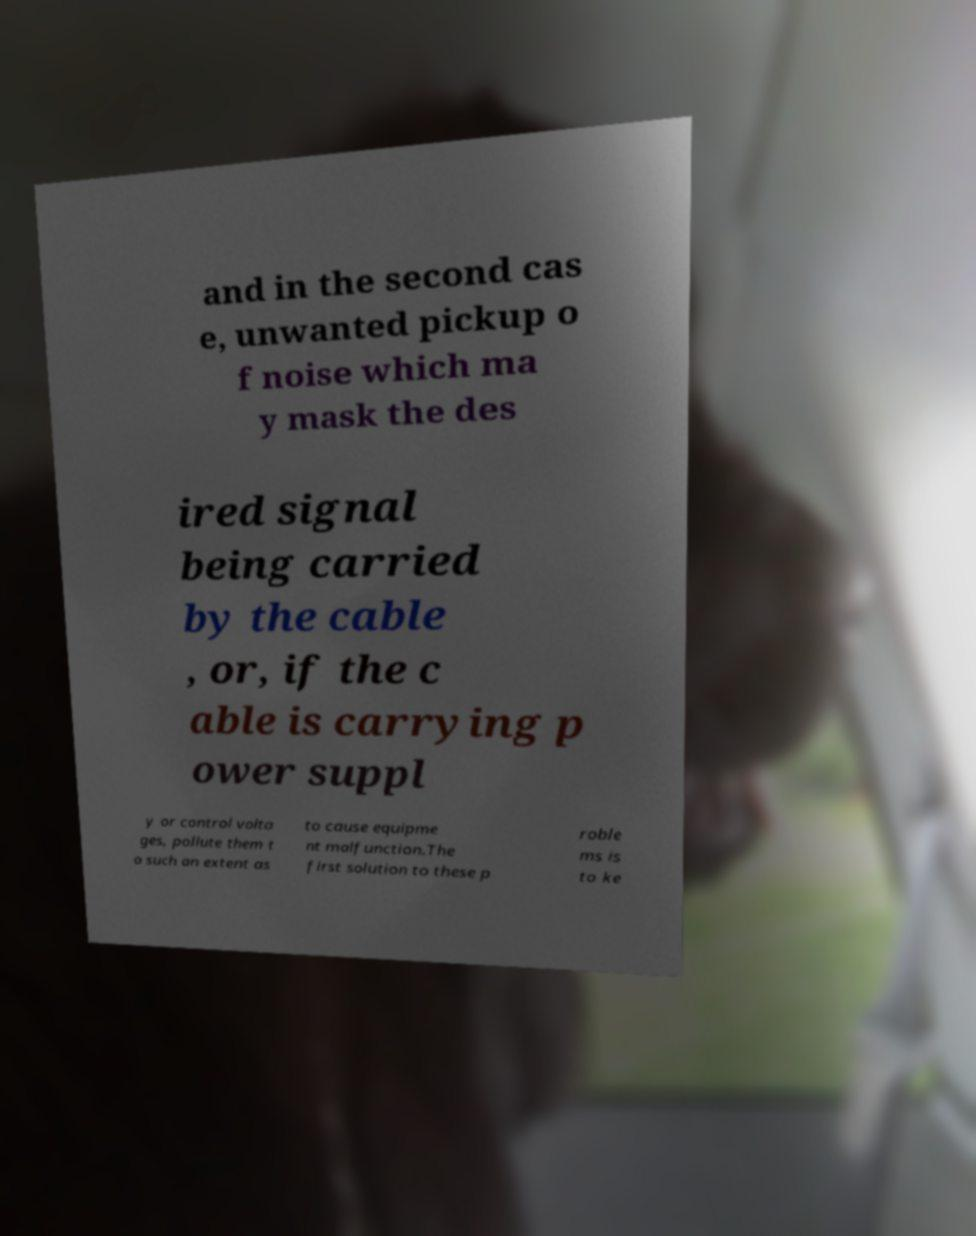Could you extract and type out the text from this image? and in the second cas e, unwanted pickup o f noise which ma y mask the des ired signal being carried by the cable , or, if the c able is carrying p ower suppl y or control volta ges, pollute them t o such an extent as to cause equipme nt malfunction.The first solution to these p roble ms is to ke 